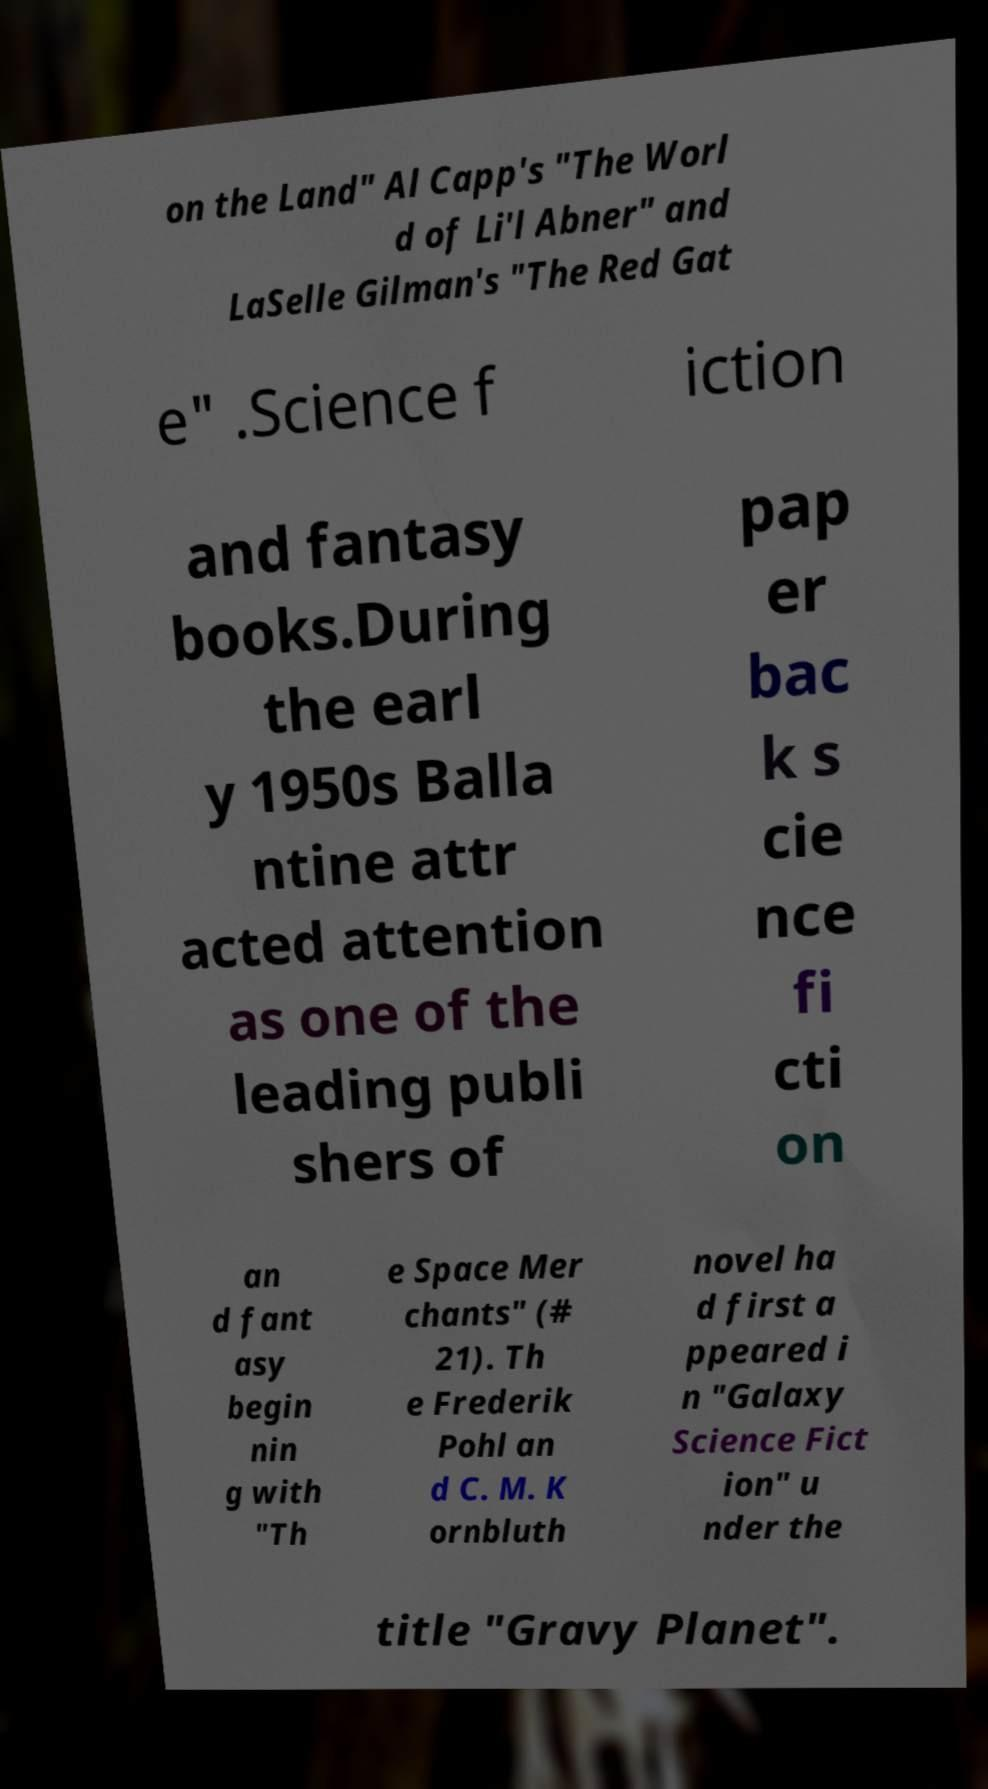There's text embedded in this image that I need extracted. Can you transcribe it verbatim? on the Land" Al Capp's "The Worl d of Li'l Abner" and LaSelle Gilman's "The Red Gat e" .Science f iction and fantasy books.During the earl y 1950s Balla ntine attr acted attention as one of the leading publi shers of pap er bac k s cie nce fi cti on an d fant asy begin nin g with "Th e Space Mer chants" (# 21). Th e Frederik Pohl an d C. M. K ornbluth novel ha d first a ppeared i n "Galaxy Science Fict ion" u nder the title "Gravy Planet". 